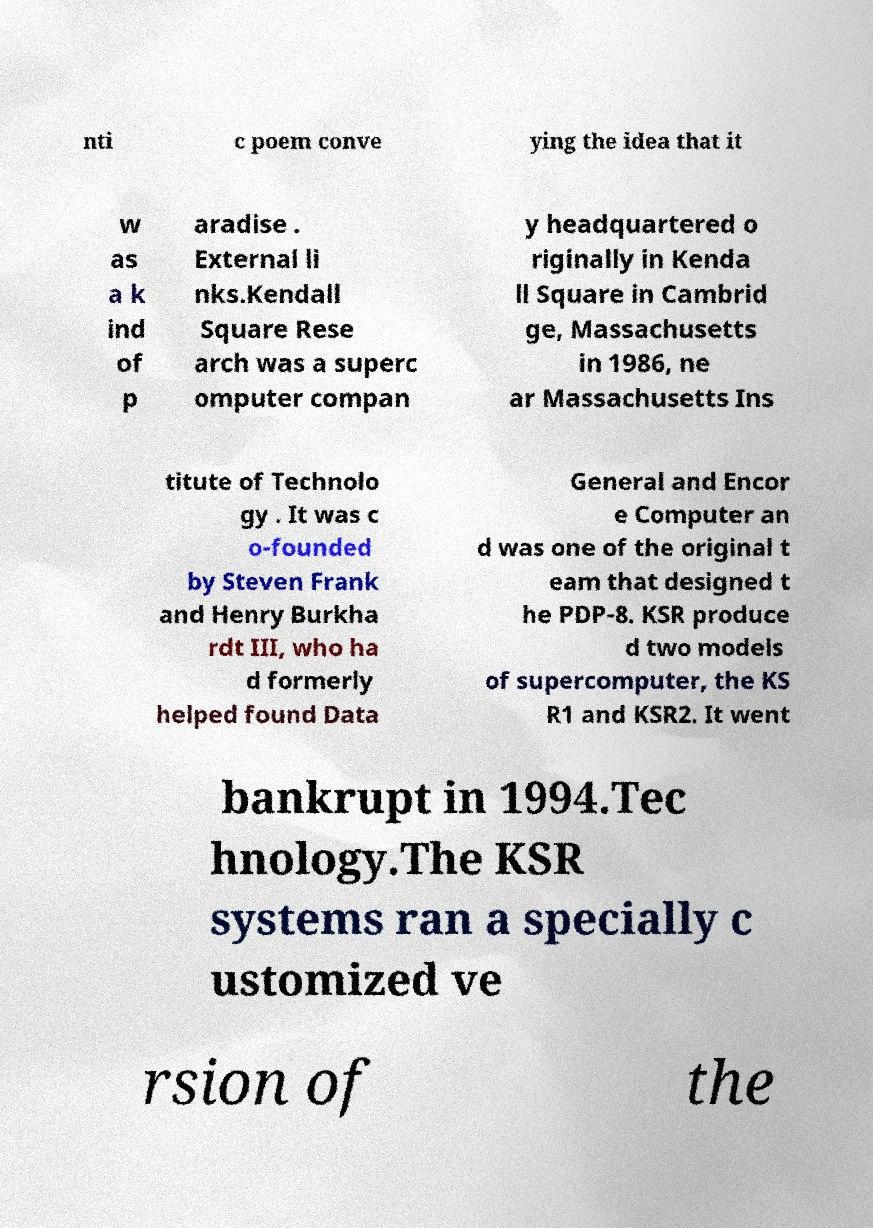For documentation purposes, I need the text within this image transcribed. Could you provide that? nti c poem conve ying the idea that it w as a k ind of p aradise . External li nks.Kendall Square Rese arch was a superc omputer compan y headquartered o riginally in Kenda ll Square in Cambrid ge, Massachusetts in 1986, ne ar Massachusetts Ins titute of Technolo gy . It was c o-founded by Steven Frank and Henry Burkha rdt III, who ha d formerly helped found Data General and Encor e Computer an d was one of the original t eam that designed t he PDP-8. KSR produce d two models of supercomputer, the KS R1 and KSR2. It went bankrupt in 1994.Tec hnology.The KSR systems ran a specially c ustomized ve rsion of the 